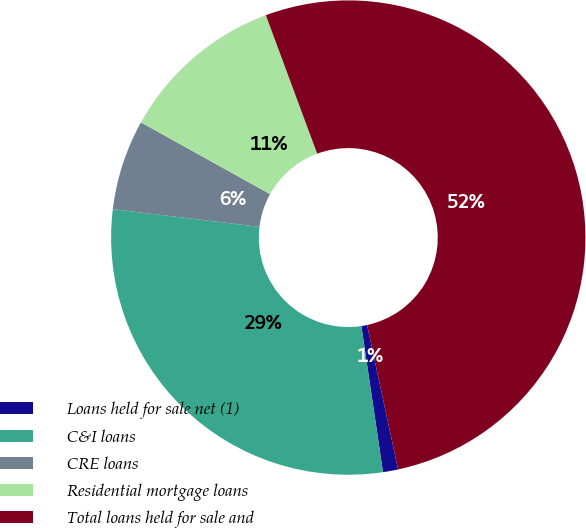Convert chart. <chart><loc_0><loc_0><loc_500><loc_500><pie_chart><fcel>Loans held for sale net (1)<fcel>C&I loans<fcel>CRE loans<fcel>Residential mortgage loans<fcel>Total loans held for sale and<nl><fcel>1.03%<fcel>29.25%<fcel>6.16%<fcel>11.28%<fcel>52.28%<nl></chart> 